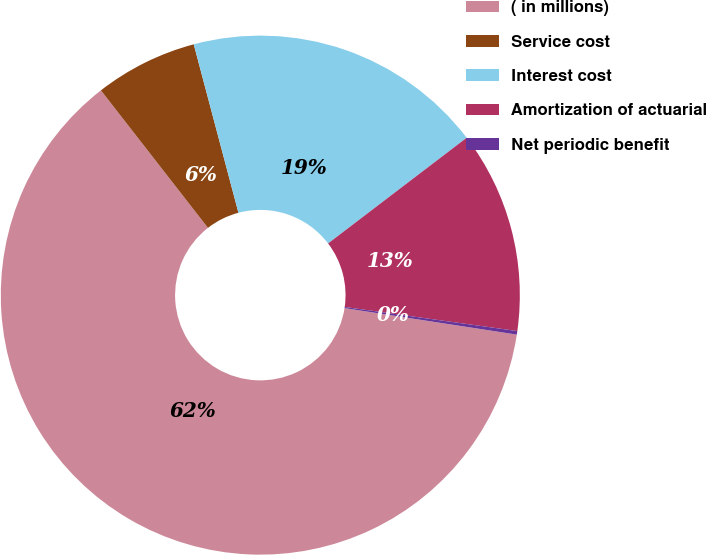<chart> <loc_0><loc_0><loc_500><loc_500><pie_chart><fcel>( in millions)<fcel>Service cost<fcel>Interest cost<fcel>Amortization of actuarial<fcel>Net periodic benefit<nl><fcel>62.04%<fcel>6.4%<fcel>18.76%<fcel>12.58%<fcel>0.22%<nl></chart> 